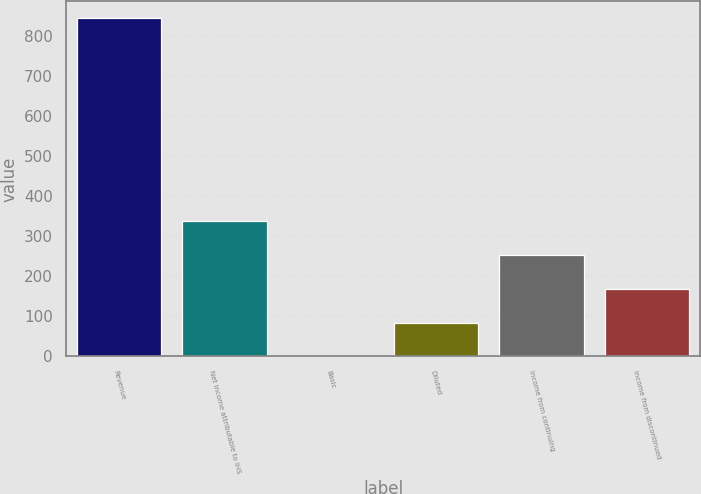<chart> <loc_0><loc_0><loc_500><loc_500><bar_chart><fcel>Revenue<fcel>Net income attributable to IHS<fcel>Basic<fcel>Diluted<fcel>Income from continuing<fcel>Income from discontinued<nl><fcel>844.2<fcel>337.76<fcel>0.16<fcel>84.56<fcel>253.36<fcel>168.96<nl></chart> 